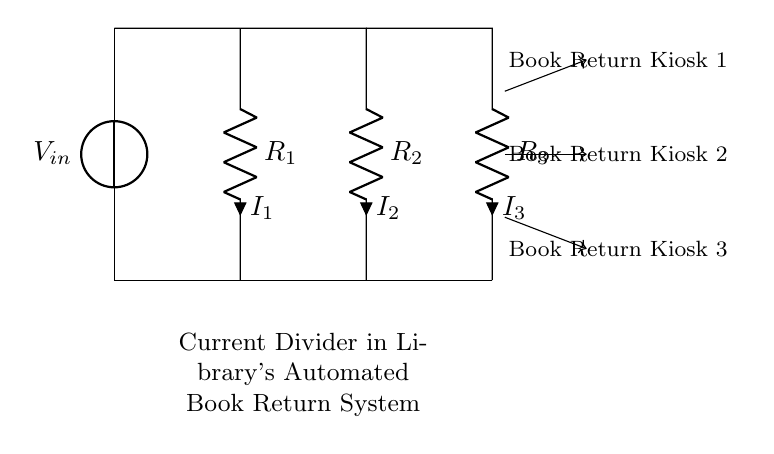What does V_in represent in the circuit? V_in represents the input voltage supplied to the current divider circuit. It's the voltage source driving the entire arrangement of resistors.
Answer: input voltage How many book return kiosks are shown? The circuit diagram indicates three book return kiosks, each represented below the current divider section.
Answer: three What are the labels for the resistors in the circuit? The resistors are labeled R_1, R_2, and R_3, which denote their specific resistance values in this current divider arrangement.
Answer: R_1, R_2, R_3 Which current flows through the first kiosk? The current flowing through the first kiosk is I_1, as indicated in the circuit diagram next to resistor R_1.
Answer: I_1 How is the total current distributed among the kiosks? The total current entering the circuit splits into I_1, I_2, and I_3 at the resistors, based on their values, demonstrating the current divider rule. This means the amount of current flowing through each leg of the circuit is inversely proportional to the resistance of that leg.
Answer: distributed by resistance values What is the relationship between resistors R_1, R_2, and R_3 in terms of current? In a current divider, the relationship is such that the current through each resistor is inversely proportional to its resistance: higher resistance means less current. Thus, if R_2 has a higher value than R_1, I_2 will be less than I_1.
Answer: inversely proportional What is the purpose of the current divider in the library's automated book return system? The purpose of the current divider is to distribute the input current among the book return kiosks in a manner that allows proper function based on their individual operational requirements. This setup ensures each kiosk receives the appropriate amount of current necessary for its operation.
Answer: distribute current effectively 